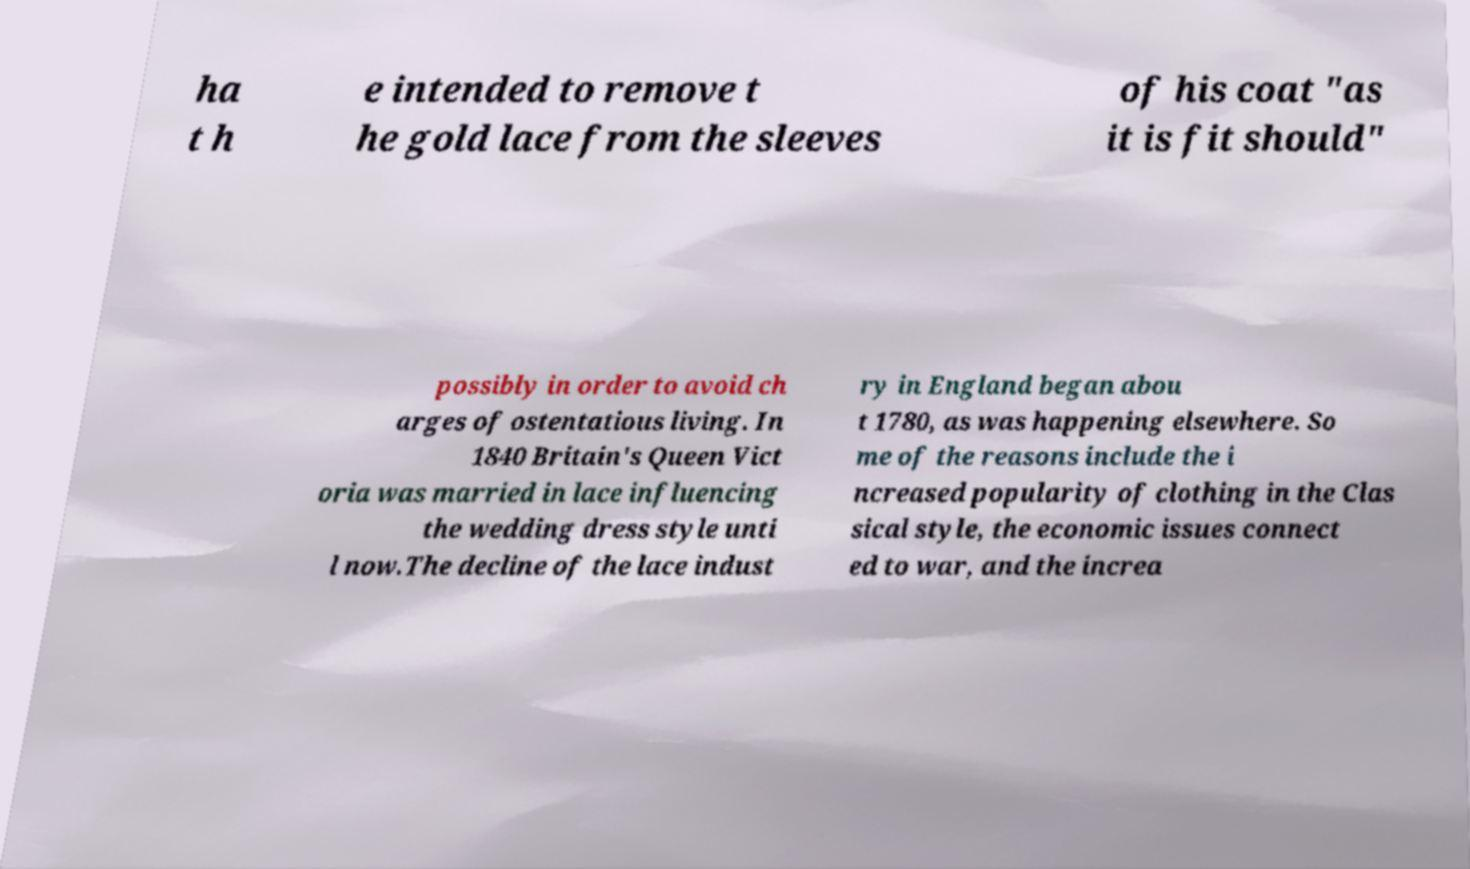Please read and relay the text visible in this image. What does it say? ha t h e intended to remove t he gold lace from the sleeves of his coat "as it is fit should" possibly in order to avoid ch arges of ostentatious living. In 1840 Britain's Queen Vict oria was married in lace influencing the wedding dress style unti l now.The decline of the lace indust ry in England began abou t 1780, as was happening elsewhere. So me of the reasons include the i ncreased popularity of clothing in the Clas sical style, the economic issues connect ed to war, and the increa 